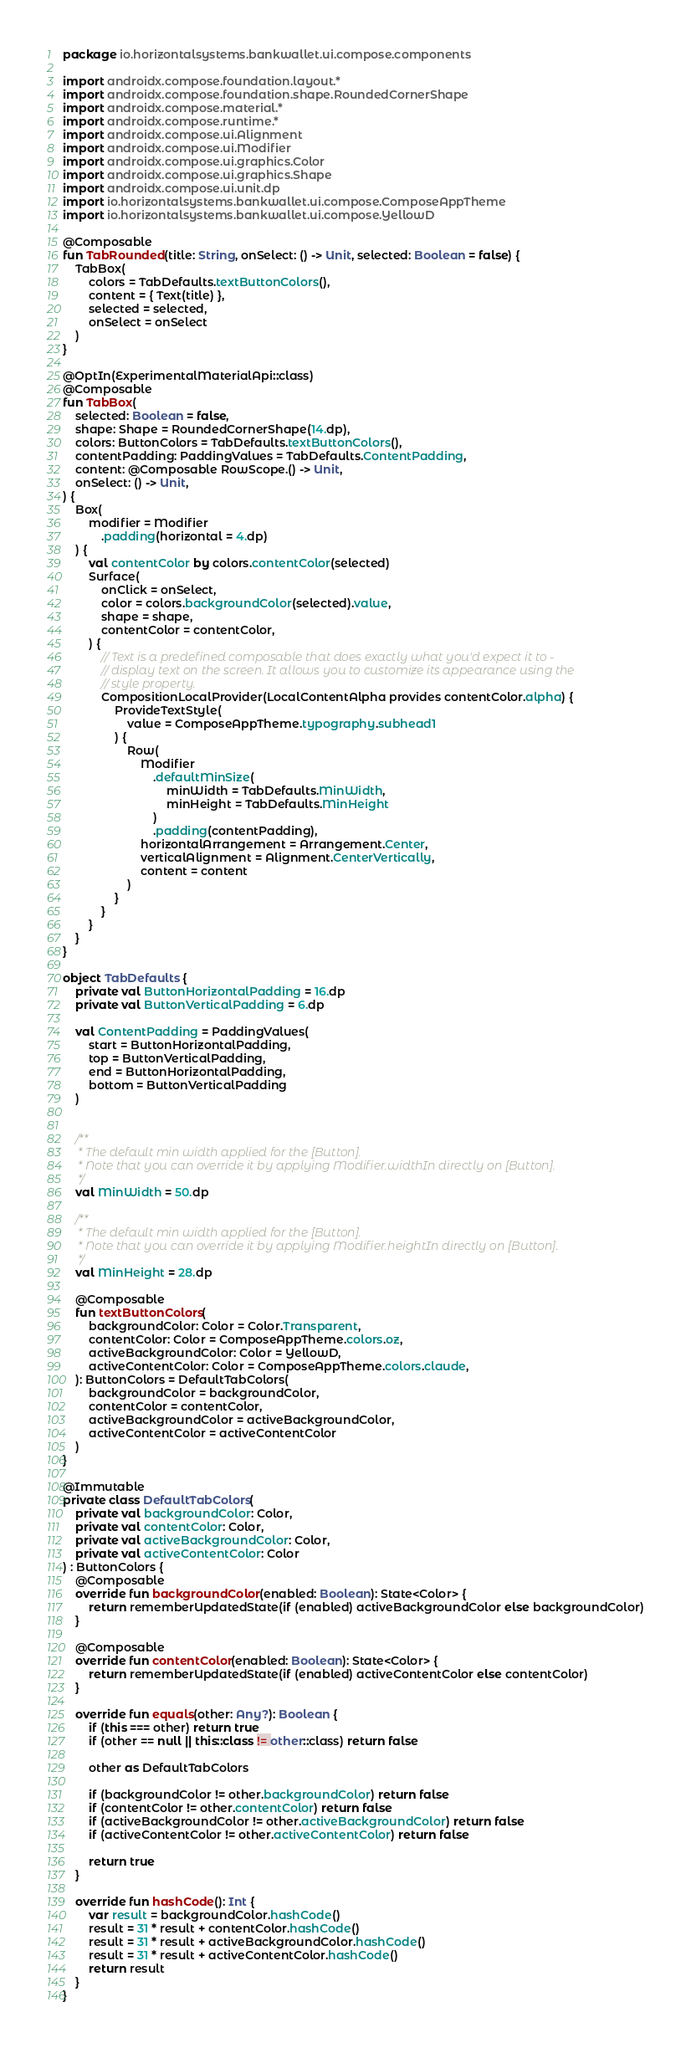Convert code to text. <code><loc_0><loc_0><loc_500><loc_500><_Kotlin_>package io.horizontalsystems.bankwallet.ui.compose.components

import androidx.compose.foundation.layout.*
import androidx.compose.foundation.shape.RoundedCornerShape
import androidx.compose.material.*
import androidx.compose.runtime.*
import androidx.compose.ui.Alignment
import androidx.compose.ui.Modifier
import androidx.compose.ui.graphics.Color
import androidx.compose.ui.graphics.Shape
import androidx.compose.ui.unit.dp
import io.horizontalsystems.bankwallet.ui.compose.ComposeAppTheme
import io.horizontalsystems.bankwallet.ui.compose.YellowD

@Composable
fun TabRounded(title: String, onSelect: () -> Unit, selected: Boolean = false) {
    TabBox(
        colors = TabDefaults.textButtonColors(),
        content = { Text(title) },
        selected = selected,
        onSelect = onSelect
    )
}

@OptIn(ExperimentalMaterialApi::class)
@Composable
fun TabBox(
    selected: Boolean = false,
    shape: Shape = RoundedCornerShape(14.dp),
    colors: ButtonColors = TabDefaults.textButtonColors(),
    contentPadding: PaddingValues = TabDefaults.ContentPadding,
    content: @Composable RowScope.() -> Unit,
    onSelect: () -> Unit,
) {
    Box(
        modifier = Modifier
            .padding(horizontal = 4.dp)
    ) {
        val contentColor by colors.contentColor(selected)
        Surface(
            onClick = onSelect,
            color = colors.backgroundColor(selected).value,
            shape = shape,
            contentColor = contentColor,
        ) {
            // Text is a predefined composable that does exactly what you'd expect it to -
            // display text on the screen. It allows you to customize its appearance using the
            // style property.
            CompositionLocalProvider(LocalContentAlpha provides contentColor.alpha) {
                ProvideTextStyle(
                    value = ComposeAppTheme.typography.subhead1
                ) {
                    Row(
                        Modifier
                            .defaultMinSize(
                                minWidth = TabDefaults.MinWidth,
                                minHeight = TabDefaults.MinHeight
                            )
                            .padding(contentPadding),
                        horizontalArrangement = Arrangement.Center,
                        verticalAlignment = Alignment.CenterVertically,
                        content = content
                    )
                }
            }
        }
    }
}

object TabDefaults {
    private val ButtonHorizontalPadding = 16.dp
    private val ButtonVerticalPadding = 6.dp

    val ContentPadding = PaddingValues(
        start = ButtonHorizontalPadding,
        top = ButtonVerticalPadding,
        end = ButtonHorizontalPadding,
        bottom = ButtonVerticalPadding
    )


    /**
     * The default min width applied for the [Button].
     * Note that you can override it by applying Modifier.widthIn directly on [Button].
     */
    val MinWidth = 50.dp

    /**
     * The default min width applied for the [Button].
     * Note that you can override it by applying Modifier.heightIn directly on [Button].
     */
    val MinHeight = 28.dp

    @Composable
    fun textButtonColors(
        backgroundColor: Color = Color.Transparent,
        contentColor: Color = ComposeAppTheme.colors.oz,
        activeBackgroundColor: Color = YellowD,
        activeContentColor: Color = ComposeAppTheme.colors.claude,
    ): ButtonColors = DefaultTabColors(
        backgroundColor = backgroundColor,
        contentColor = contentColor,
        activeBackgroundColor = activeBackgroundColor,
        activeContentColor = activeContentColor
    )
}

@Immutable
private class DefaultTabColors(
    private val backgroundColor: Color,
    private val contentColor: Color,
    private val activeBackgroundColor: Color,
    private val activeContentColor: Color
) : ButtonColors {
    @Composable
    override fun backgroundColor(enabled: Boolean): State<Color> {
        return rememberUpdatedState(if (enabled) activeBackgroundColor else backgroundColor)
    }

    @Composable
    override fun contentColor(enabled: Boolean): State<Color> {
        return rememberUpdatedState(if (enabled) activeContentColor else contentColor)
    }

    override fun equals(other: Any?): Boolean {
        if (this === other) return true
        if (other == null || this::class != other::class) return false

        other as DefaultTabColors

        if (backgroundColor != other.backgroundColor) return false
        if (contentColor != other.contentColor) return false
        if (activeBackgroundColor != other.activeBackgroundColor) return false
        if (activeContentColor != other.activeContentColor) return false

        return true
    }

    override fun hashCode(): Int {
        var result = backgroundColor.hashCode()
        result = 31 * result + contentColor.hashCode()
        result = 31 * result + activeBackgroundColor.hashCode()
        result = 31 * result + activeContentColor.hashCode()
        return result
    }
}</code> 